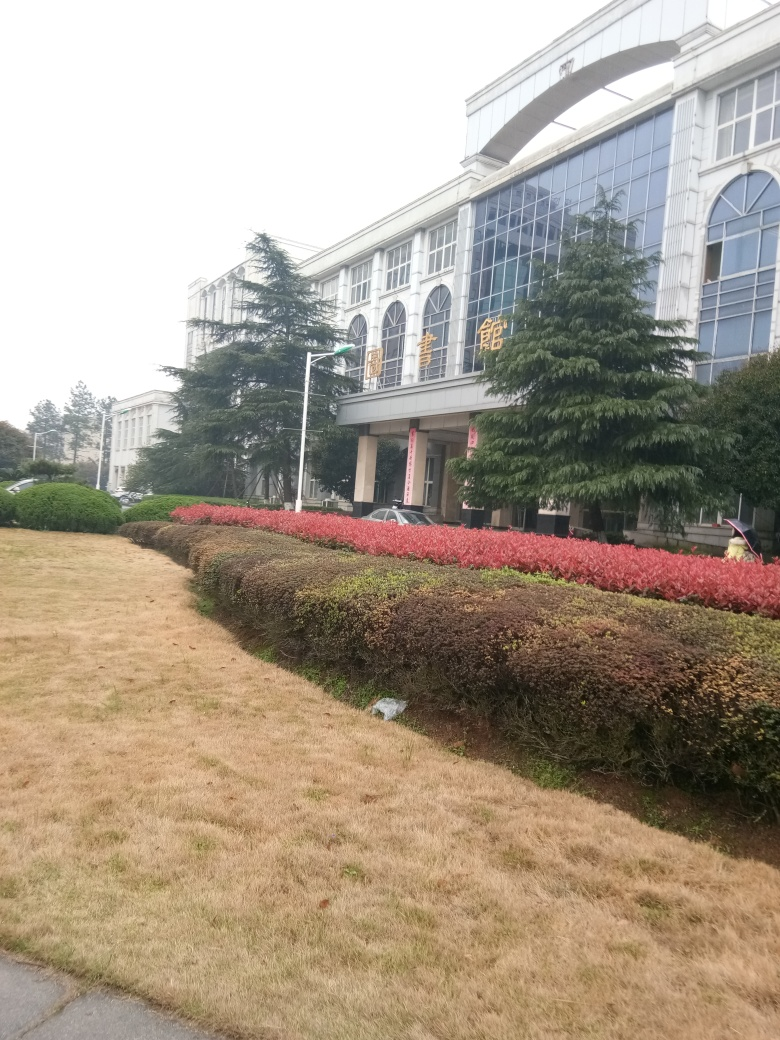How is the image quality? The image quality appears to be mediocre. There's visible pixelation and blurriness which suggests a low resolution, and the lighting conditions are less than ideal, resulting in a somewhat dull appearance. However, the subject of the photo, the building and the landscape, are clear enough to discern details. 